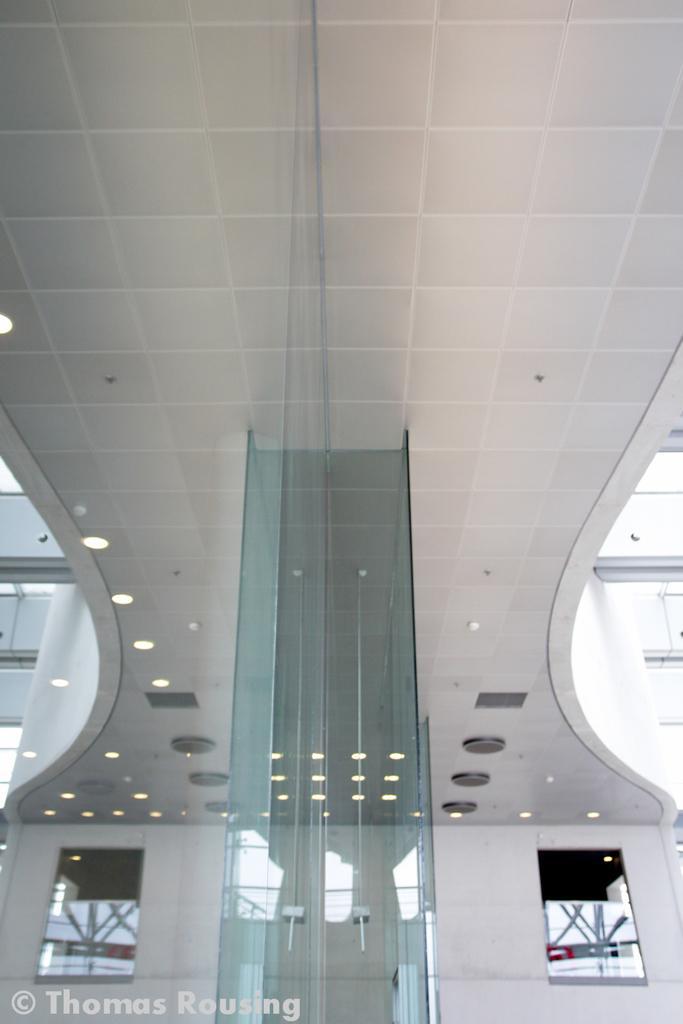Can you describe this image briefly? In this image I can see glass, number of lights and here I can see watermark. 